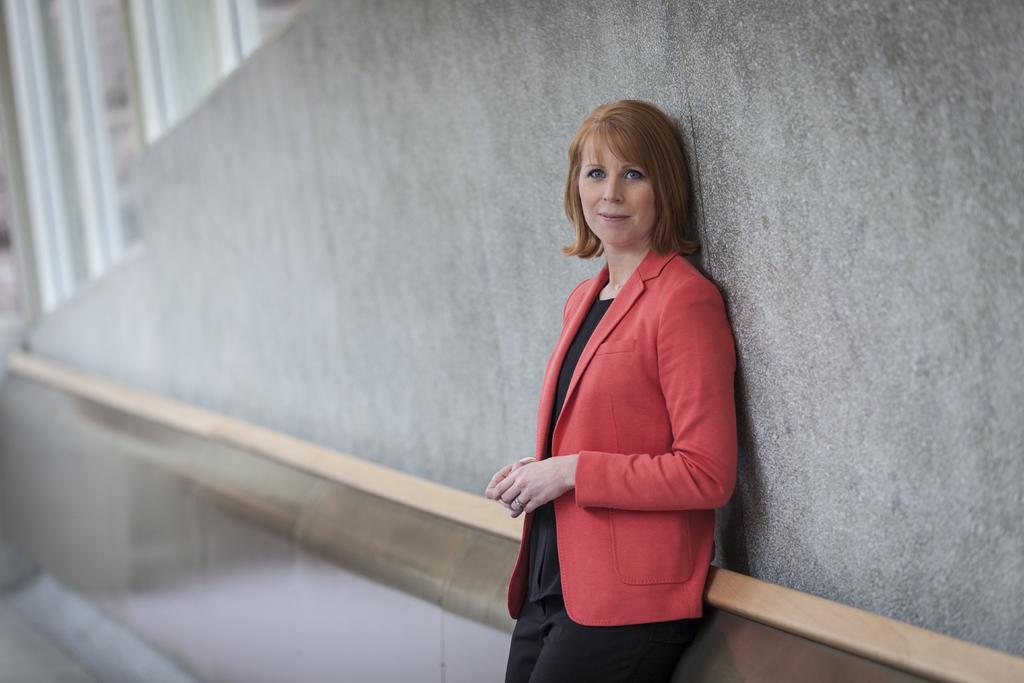In one or two sentences, can you explain what this image depicts? In this image we can see a woman standing. In the background we can see the wall. 